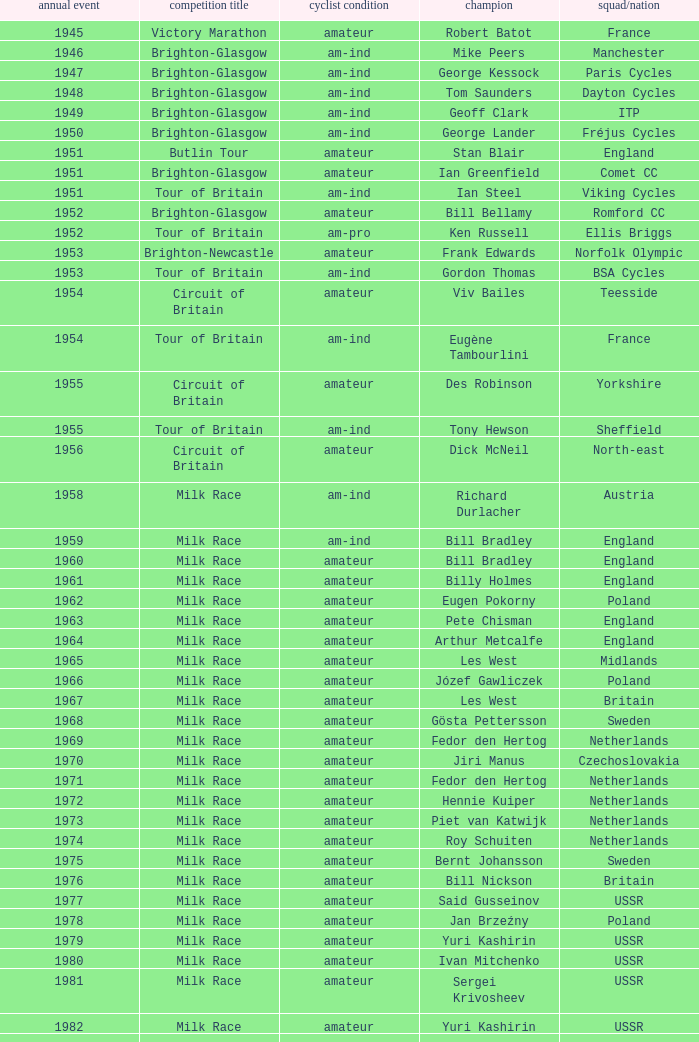Who was the winner in 1973 with an amateur rider status? Piet van Katwijk. 